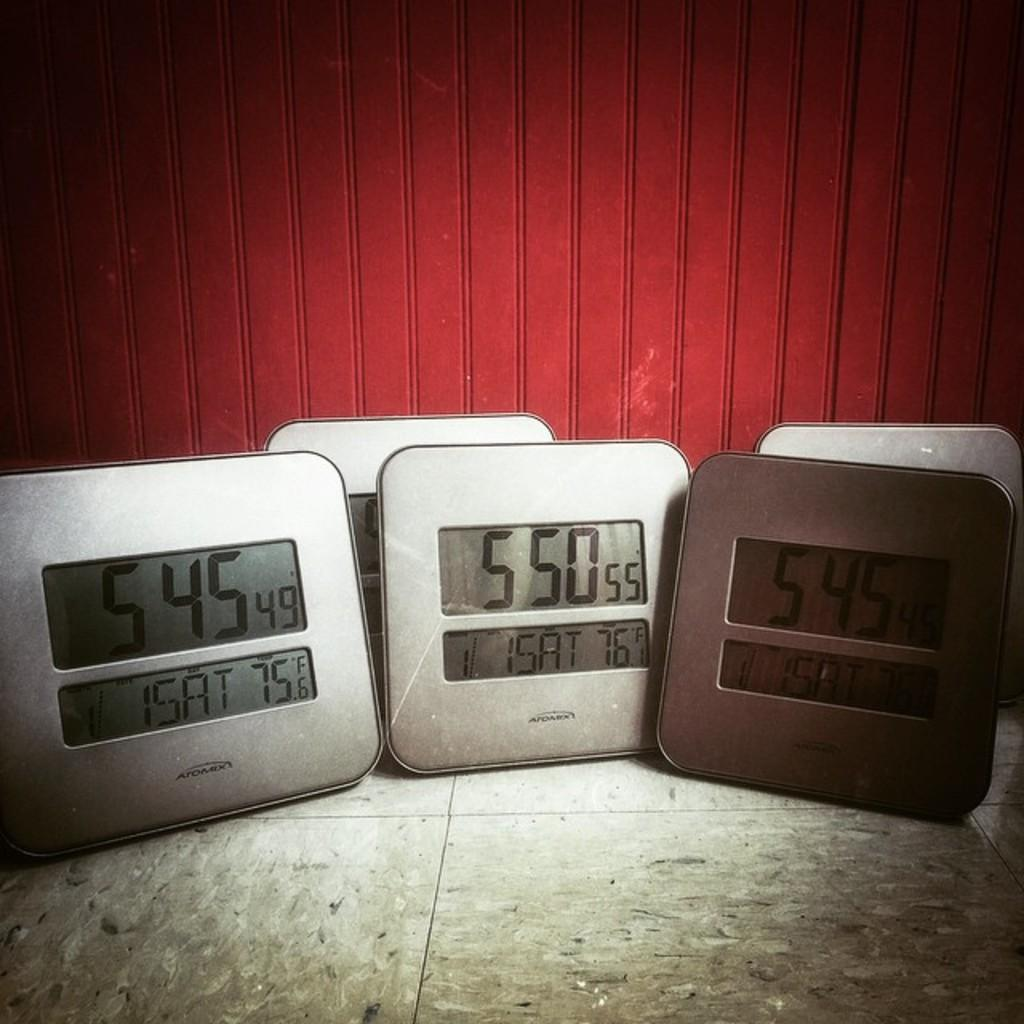<image>
Describe the image concisely. A display of Atomix digital clocks sitting on a tile floor 